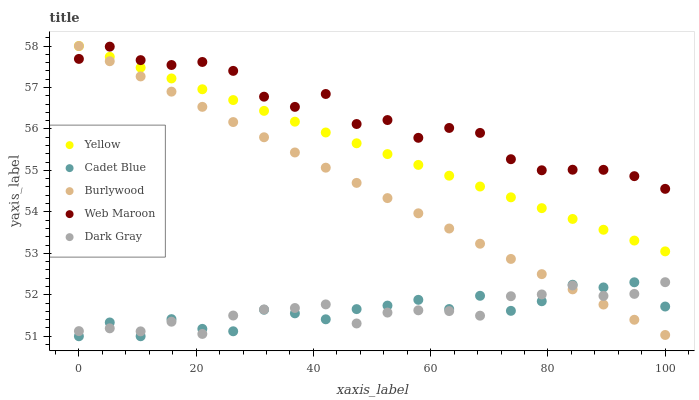Does Dark Gray have the minimum area under the curve?
Answer yes or no. Yes. Does Web Maroon have the maximum area under the curve?
Answer yes or no. Yes. Does Cadet Blue have the minimum area under the curve?
Answer yes or no. No. Does Cadet Blue have the maximum area under the curve?
Answer yes or no. No. Is Burlywood the smoothest?
Answer yes or no. Yes. Is Cadet Blue the roughest?
Answer yes or no. Yes. Is Dark Gray the smoothest?
Answer yes or no. No. Is Dark Gray the roughest?
Answer yes or no. No. Does Cadet Blue have the lowest value?
Answer yes or no. Yes. Does Dark Gray have the lowest value?
Answer yes or no. No. Does Yellow have the highest value?
Answer yes or no. Yes. Does Dark Gray have the highest value?
Answer yes or no. No. Is Dark Gray less than Web Maroon?
Answer yes or no. Yes. Is Yellow greater than Dark Gray?
Answer yes or no. Yes. Does Dark Gray intersect Burlywood?
Answer yes or no. Yes. Is Dark Gray less than Burlywood?
Answer yes or no. No. Is Dark Gray greater than Burlywood?
Answer yes or no. No. Does Dark Gray intersect Web Maroon?
Answer yes or no. No. 